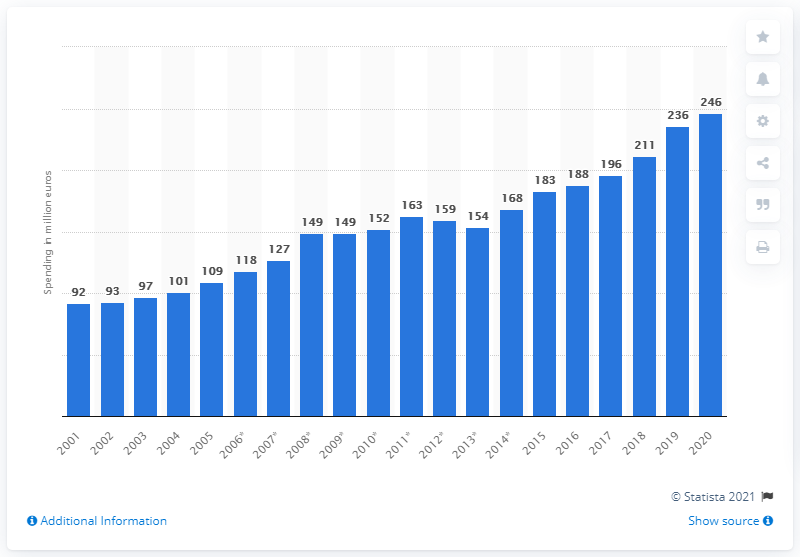Give some essential details in this illustration. In 2020, Beiersdorf's worldwide R&D spending amounted to 246 million. 